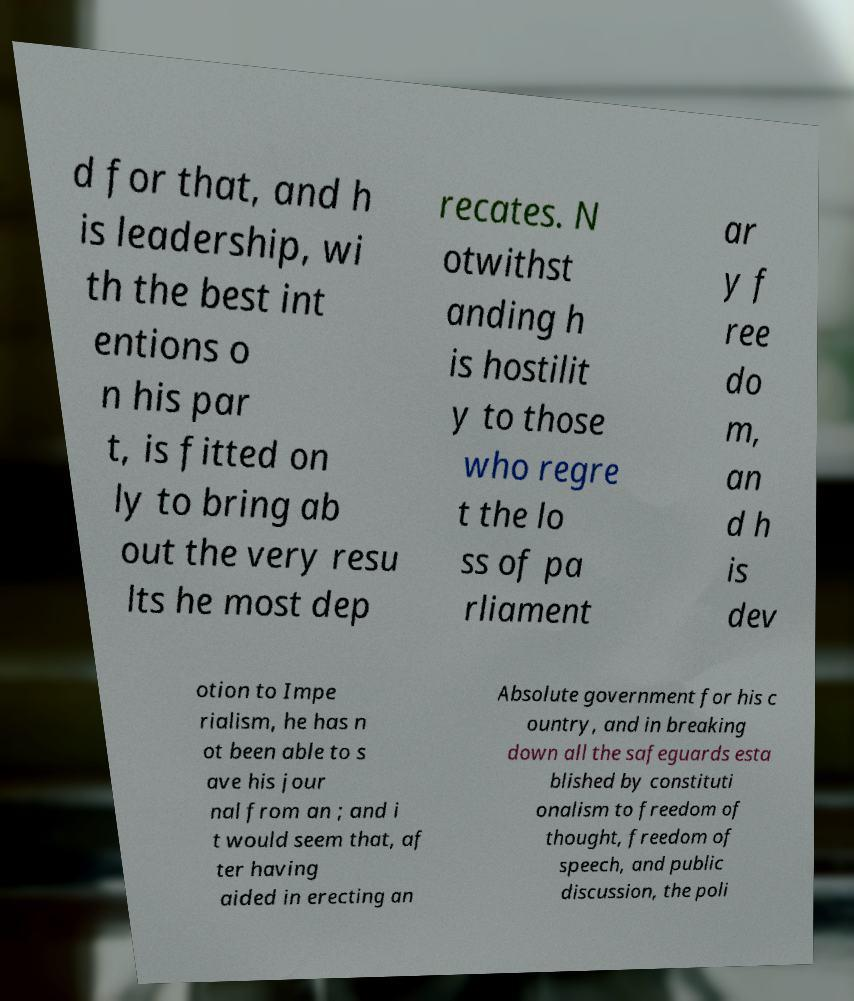Could you extract and type out the text from this image? d for that, and h is leadership, wi th the best int entions o n his par t, is fitted on ly to bring ab out the very resu lts he most dep recates. N otwithst anding h is hostilit y to those who regre t the lo ss of pa rliament ar y f ree do m, an d h is dev otion to Impe rialism, he has n ot been able to s ave his jour nal from an ; and i t would seem that, af ter having aided in erecting an Absolute government for his c ountry, and in breaking down all the safeguards esta blished by constituti onalism to freedom of thought, freedom of speech, and public discussion, the poli 